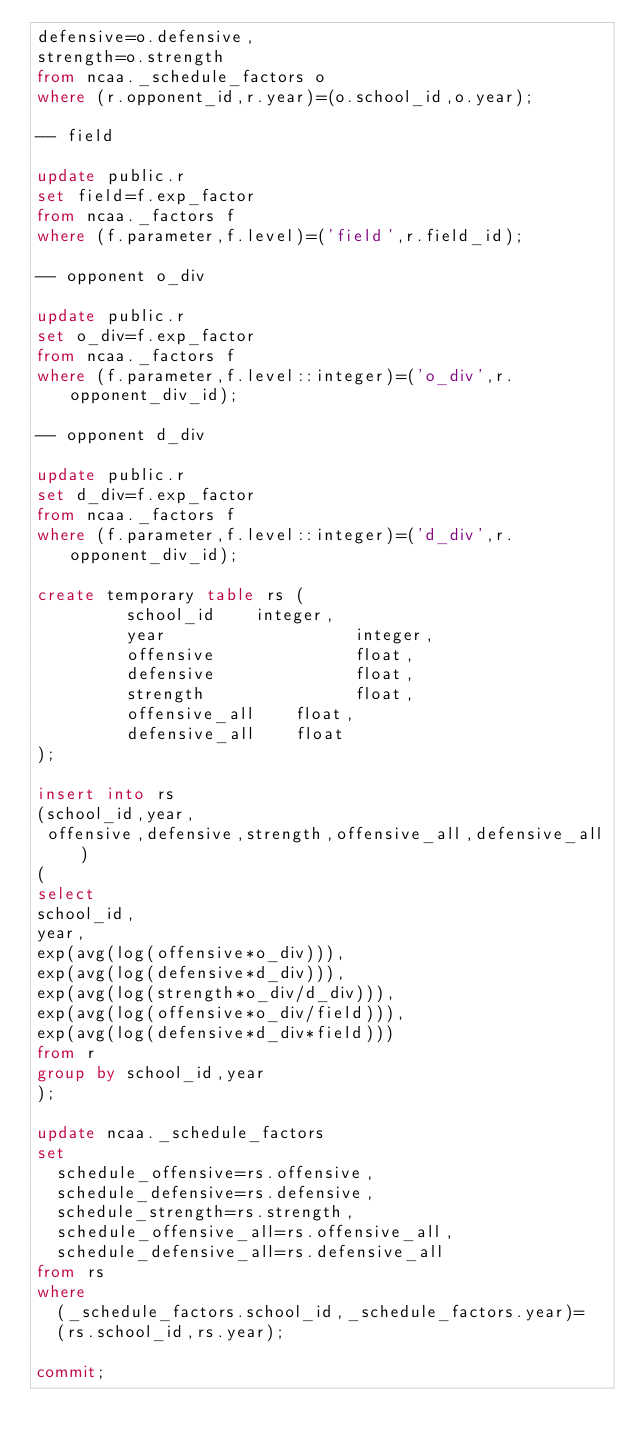<code> <loc_0><loc_0><loc_500><loc_500><_SQL_>defensive=o.defensive,
strength=o.strength
from ncaa._schedule_factors o
where (r.opponent_id,r.year)=(o.school_id,o.year);

-- field

update public.r
set field=f.exp_factor
from ncaa._factors f
where (f.parameter,f.level)=('field',r.field_id);

-- opponent o_div

update public.r
set o_div=f.exp_factor
from ncaa._factors f
where (f.parameter,f.level::integer)=('o_div',r.opponent_div_id);

-- opponent d_div

update public.r
set d_div=f.exp_factor
from ncaa._factors f
where (f.parameter,f.level::integer)=('d_div',r.opponent_div_id);

create temporary table rs (
         school_id		integer,
         year                   integer,
         offensive              float,
         defensive              float,
         strength               float,
         offensive_all		float,
         defensive_all		float
);

insert into rs
(school_id,year,
 offensive,defensive,strength,offensive_all,defensive_all)
(
select
school_id,
year,
exp(avg(log(offensive*o_div))),
exp(avg(log(defensive*d_div))),
exp(avg(log(strength*o_div/d_div))),
exp(avg(log(offensive*o_div/field))),
exp(avg(log(defensive*d_div*field)))
from r
group by school_id,year
);

update ncaa._schedule_factors
set
  schedule_offensive=rs.offensive,
  schedule_defensive=rs.defensive,
  schedule_strength=rs.strength,
  schedule_offensive_all=rs.offensive_all,
  schedule_defensive_all=rs.defensive_all
from rs
where
  (_schedule_factors.school_id,_schedule_factors.year)=
  (rs.school_id,rs.year);

commit;
</code> 